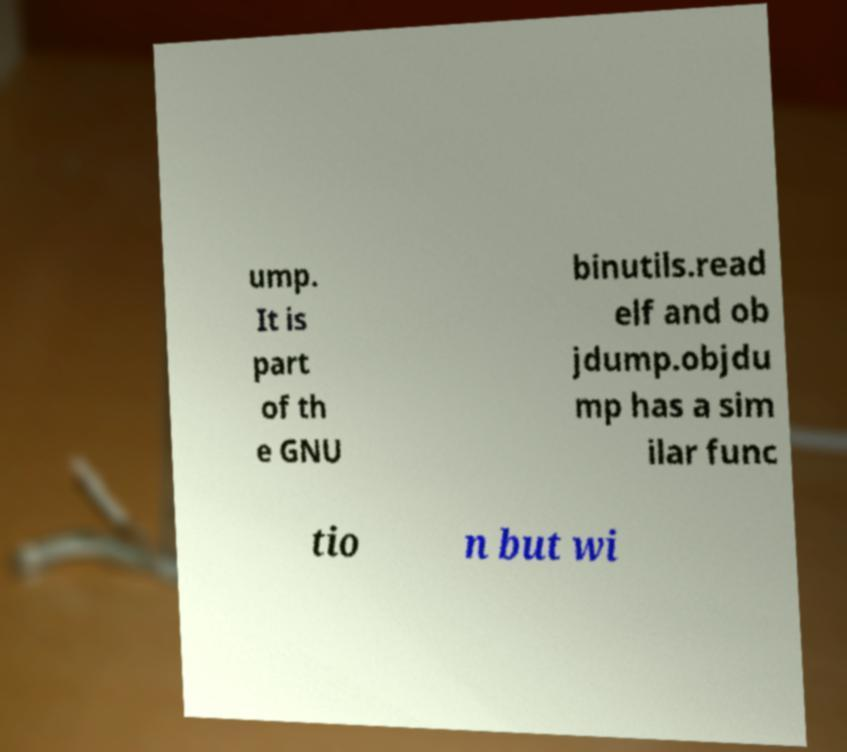Please read and relay the text visible in this image. What does it say? ump. It is part of th e GNU binutils.read elf and ob jdump.objdu mp has a sim ilar func tio n but wi 